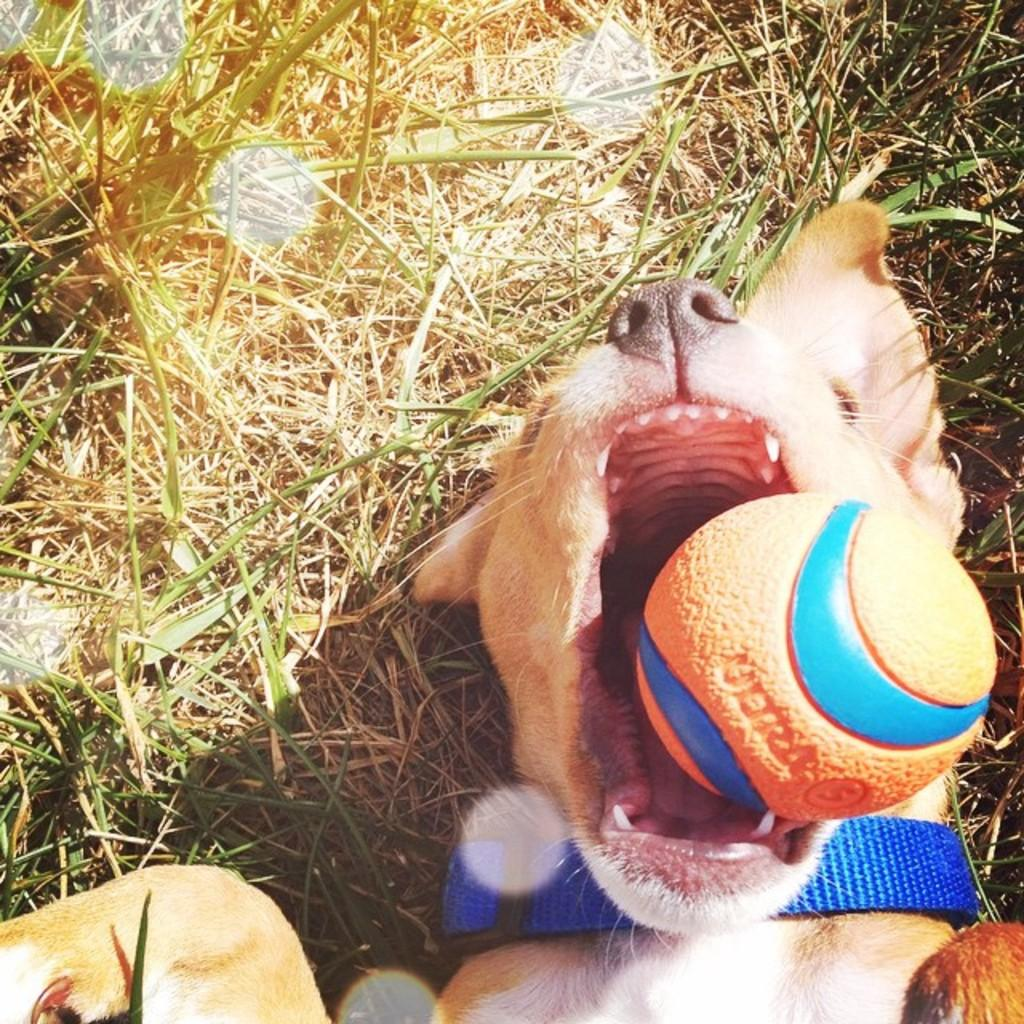What type of animal is present in the image? There is a dog in the image. What is the dog holding or interacting with in the image? The dog has a ball near its mouth. What can be seen in the background of the image? There is grass in the background of the image. What type of plastic material is being used for the feast in the image? There is no feast or plastic material present in the image; it features a dog with a ball near its mouth and grass in the background. 